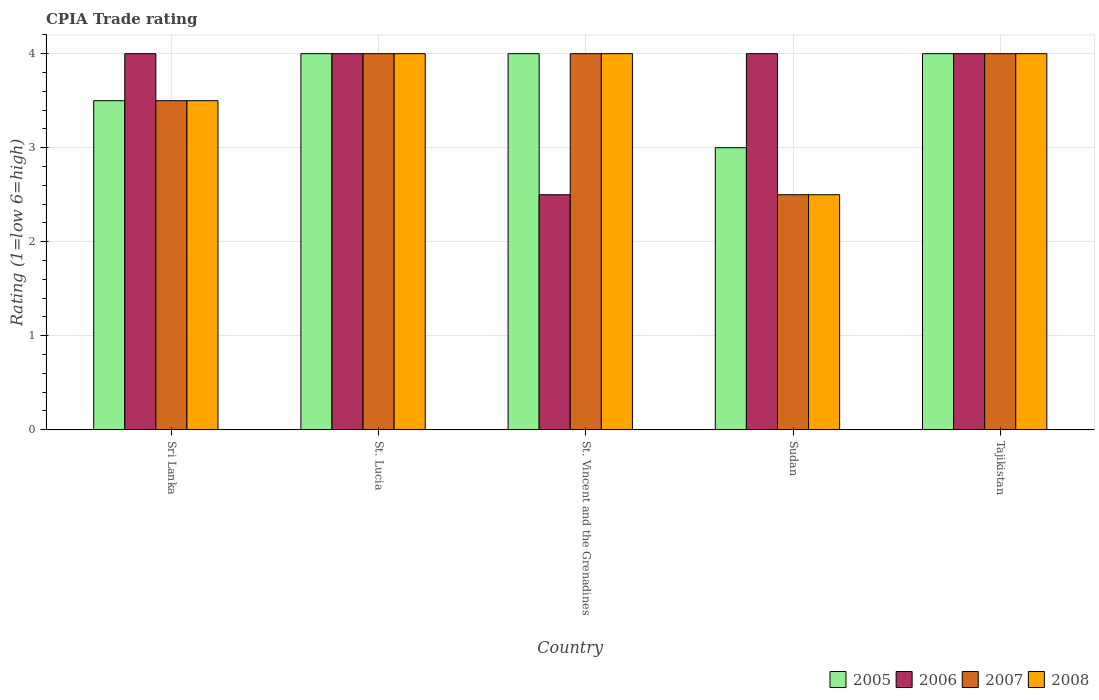How many different coloured bars are there?
Make the answer very short. 4. Are the number of bars on each tick of the X-axis equal?
Give a very brief answer. Yes. How many bars are there on the 5th tick from the left?
Provide a short and direct response. 4. What is the label of the 4th group of bars from the left?
Your answer should be very brief. Sudan. What is the CPIA rating in 2006 in St. Vincent and the Grenadines?
Ensure brevity in your answer.  2.5. Across all countries, what is the maximum CPIA rating in 2007?
Ensure brevity in your answer.  4. In which country was the CPIA rating in 2008 maximum?
Offer a very short reply. St. Lucia. In which country was the CPIA rating in 2005 minimum?
Give a very brief answer. Sudan. What is the total CPIA rating in 2008 in the graph?
Your response must be concise. 18. What is the difference between the CPIA rating in 2008 in St. Vincent and the Grenadines and that in Tajikistan?
Make the answer very short. 0. What is the difference between the CPIA rating in 2006 in St. Lucia and the CPIA rating in 2005 in St. Vincent and the Grenadines?
Give a very brief answer. 0. What is the average CPIA rating in 2007 per country?
Offer a terse response. 3.6. What is the difference between the CPIA rating of/in 2005 and CPIA rating of/in 2006 in Sudan?
Provide a succinct answer. -1. In how many countries, is the CPIA rating in 2005 greater than 1.4?
Offer a very short reply. 5. What is the ratio of the CPIA rating in 2006 in Sudan to that in Tajikistan?
Your answer should be very brief. 1. Is the CPIA rating in 2007 in Sri Lanka less than that in St. Lucia?
Offer a very short reply. Yes. What is the difference between the highest and the lowest CPIA rating in 2007?
Ensure brevity in your answer.  1.5. In how many countries, is the CPIA rating in 2007 greater than the average CPIA rating in 2007 taken over all countries?
Your response must be concise. 3. Is the sum of the CPIA rating in 2006 in St. Lucia and Tajikistan greater than the maximum CPIA rating in 2005 across all countries?
Your response must be concise. Yes. Is it the case that in every country, the sum of the CPIA rating in 2008 and CPIA rating in 2005 is greater than the CPIA rating in 2006?
Provide a short and direct response. Yes. Are all the bars in the graph horizontal?
Offer a very short reply. No. How many countries are there in the graph?
Ensure brevity in your answer.  5. What is the difference between two consecutive major ticks on the Y-axis?
Provide a succinct answer. 1. Does the graph contain any zero values?
Provide a short and direct response. No. What is the title of the graph?
Give a very brief answer. CPIA Trade rating. Does "1991" appear as one of the legend labels in the graph?
Offer a terse response. No. What is the label or title of the X-axis?
Provide a short and direct response. Country. What is the label or title of the Y-axis?
Provide a succinct answer. Rating (1=low 6=high). What is the Rating (1=low 6=high) in 2006 in Sri Lanka?
Offer a terse response. 4. What is the Rating (1=low 6=high) in 2006 in St. Lucia?
Offer a very short reply. 4. What is the Rating (1=low 6=high) in 2005 in St. Vincent and the Grenadines?
Offer a very short reply. 4. What is the Rating (1=low 6=high) in 2006 in St. Vincent and the Grenadines?
Your response must be concise. 2.5. What is the Rating (1=low 6=high) in 2006 in Sudan?
Give a very brief answer. 4. What is the Rating (1=low 6=high) in 2005 in Tajikistan?
Keep it short and to the point. 4. What is the Rating (1=low 6=high) in 2006 in Tajikistan?
Your answer should be very brief. 4. What is the Rating (1=low 6=high) of 2007 in Tajikistan?
Provide a short and direct response. 4. Across all countries, what is the maximum Rating (1=low 6=high) of 2006?
Your answer should be compact. 4. Across all countries, what is the minimum Rating (1=low 6=high) in 2006?
Provide a succinct answer. 2.5. Across all countries, what is the minimum Rating (1=low 6=high) of 2008?
Keep it short and to the point. 2.5. What is the total Rating (1=low 6=high) of 2005 in the graph?
Your answer should be very brief. 18.5. What is the total Rating (1=low 6=high) of 2007 in the graph?
Make the answer very short. 18. What is the difference between the Rating (1=low 6=high) of 2007 in Sri Lanka and that in St. Lucia?
Your response must be concise. -0.5. What is the difference between the Rating (1=low 6=high) of 2008 in Sri Lanka and that in St. Lucia?
Make the answer very short. -0.5. What is the difference between the Rating (1=low 6=high) in 2005 in Sri Lanka and that in St. Vincent and the Grenadines?
Ensure brevity in your answer.  -0.5. What is the difference between the Rating (1=low 6=high) of 2006 in Sri Lanka and that in St. Vincent and the Grenadines?
Make the answer very short. 1.5. What is the difference between the Rating (1=low 6=high) of 2008 in Sri Lanka and that in St. Vincent and the Grenadines?
Offer a terse response. -0.5. What is the difference between the Rating (1=low 6=high) of 2005 in Sri Lanka and that in Sudan?
Make the answer very short. 0.5. What is the difference between the Rating (1=low 6=high) of 2007 in Sri Lanka and that in Tajikistan?
Offer a very short reply. -0.5. What is the difference between the Rating (1=low 6=high) in 2008 in Sri Lanka and that in Tajikistan?
Provide a short and direct response. -0.5. What is the difference between the Rating (1=low 6=high) of 2005 in St. Lucia and that in St. Vincent and the Grenadines?
Your answer should be very brief. 0. What is the difference between the Rating (1=low 6=high) of 2007 in St. Lucia and that in St. Vincent and the Grenadines?
Your answer should be very brief. 0. What is the difference between the Rating (1=low 6=high) in 2006 in St. Lucia and that in Sudan?
Keep it short and to the point. 0. What is the difference between the Rating (1=low 6=high) in 2005 in St. Lucia and that in Tajikistan?
Your answer should be very brief. 0. What is the difference between the Rating (1=low 6=high) in 2007 in St. Lucia and that in Tajikistan?
Provide a succinct answer. 0. What is the difference between the Rating (1=low 6=high) of 2006 in St. Vincent and the Grenadines and that in Sudan?
Give a very brief answer. -1.5. What is the difference between the Rating (1=low 6=high) of 2007 in St. Vincent and the Grenadines and that in Sudan?
Your answer should be very brief. 1.5. What is the difference between the Rating (1=low 6=high) in 2006 in St. Vincent and the Grenadines and that in Tajikistan?
Provide a short and direct response. -1.5. What is the difference between the Rating (1=low 6=high) of 2006 in Sudan and that in Tajikistan?
Give a very brief answer. 0. What is the difference between the Rating (1=low 6=high) of 2007 in Sudan and that in Tajikistan?
Your answer should be compact. -1.5. What is the difference between the Rating (1=low 6=high) of 2008 in Sudan and that in Tajikistan?
Your answer should be very brief. -1.5. What is the difference between the Rating (1=low 6=high) of 2005 in Sri Lanka and the Rating (1=low 6=high) of 2008 in St. Lucia?
Your response must be concise. -0.5. What is the difference between the Rating (1=low 6=high) of 2006 in Sri Lanka and the Rating (1=low 6=high) of 2007 in St. Lucia?
Provide a succinct answer. 0. What is the difference between the Rating (1=low 6=high) in 2006 in Sri Lanka and the Rating (1=low 6=high) in 2008 in St. Lucia?
Keep it short and to the point. 0. What is the difference between the Rating (1=low 6=high) of 2007 in Sri Lanka and the Rating (1=low 6=high) of 2008 in St. Lucia?
Offer a terse response. -0.5. What is the difference between the Rating (1=low 6=high) in 2005 in Sri Lanka and the Rating (1=low 6=high) in 2006 in St. Vincent and the Grenadines?
Provide a succinct answer. 1. What is the difference between the Rating (1=low 6=high) of 2005 in Sri Lanka and the Rating (1=low 6=high) of 2008 in St. Vincent and the Grenadines?
Make the answer very short. -0.5. What is the difference between the Rating (1=low 6=high) in 2005 in Sri Lanka and the Rating (1=low 6=high) in 2007 in Sudan?
Your answer should be compact. 1. What is the difference between the Rating (1=low 6=high) in 2006 in Sri Lanka and the Rating (1=low 6=high) in 2008 in Sudan?
Ensure brevity in your answer.  1.5. What is the difference between the Rating (1=low 6=high) of 2005 in Sri Lanka and the Rating (1=low 6=high) of 2006 in Tajikistan?
Make the answer very short. -0.5. What is the difference between the Rating (1=low 6=high) of 2006 in Sri Lanka and the Rating (1=low 6=high) of 2008 in Tajikistan?
Provide a succinct answer. 0. What is the difference between the Rating (1=low 6=high) in 2005 in St. Lucia and the Rating (1=low 6=high) in 2007 in St. Vincent and the Grenadines?
Offer a terse response. 0. What is the difference between the Rating (1=low 6=high) in 2006 in St. Lucia and the Rating (1=low 6=high) in 2008 in St. Vincent and the Grenadines?
Your answer should be compact. 0. What is the difference between the Rating (1=low 6=high) of 2005 in St. Lucia and the Rating (1=low 6=high) of 2006 in Sudan?
Ensure brevity in your answer.  0. What is the difference between the Rating (1=low 6=high) of 2006 in St. Lucia and the Rating (1=low 6=high) of 2008 in Sudan?
Offer a very short reply. 1.5. What is the difference between the Rating (1=low 6=high) in 2007 in St. Lucia and the Rating (1=low 6=high) in 2008 in Sudan?
Offer a terse response. 1.5. What is the difference between the Rating (1=low 6=high) in 2005 in St. Lucia and the Rating (1=low 6=high) in 2006 in Tajikistan?
Your answer should be compact. 0. What is the difference between the Rating (1=low 6=high) in 2005 in St. Lucia and the Rating (1=low 6=high) in 2008 in Tajikistan?
Give a very brief answer. 0. What is the difference between the Rating (1=low 6=high) of 2006 in St. Lucia and the Rating (1=low 6=high) of 2008 in Tajikistan?
Keep it short and to the point. 0. What is the difference between the Rating (1=low 6=high) of 2007 in St. Lucia and the Rating (1=low 6=high) of 2008 in Tajikistan?
Your answer should be compact. 0. What is the difference between the Rating (1=low 6=high) in 2006 in St. Vincent and the Grenadines and the Rating (1=low 6=high) in 2008 in Sudan?
Keep it short and to the point. 0. What is the difference between the Rating (1=low 6=high) of 2005 in St. Vincent and the Grenadines and the Rating (1=low 6=high) of 2006 in Tajikistan?
Provide a succinct answer. 0. What is the difference between the Rating (1=low 6=high) of 2005 in St. Vincent and the Grenadines and the Rating (1=low 6=high) of 2007 in Tajikistan?
Offer a very short reply. 0. What is the difference between the Rating (1=low 6=high) of 2005 in Sudan and the Rating (1=low 6=high) of 2008 in Tajikistan?
Offer a very short reply. -1. What is the difference between the Rating (1=low 6=high) of 2007 in Sudan and the Rating (1=low 6=high) of 2008 in Tajikistan?
Your answer should be very brief. -1.5. What is the average Rating (1=low 6=high) in 2005 per country?
Offer a terse response. 3.7. What is the average Rating (1=low 6=high) in 2006 per country?
Make the answer very short. 3.7. What is the average Rating (1=low 6=high) in 2007 per country?
Give a very brief answer. 3.6. What is the average Rating (1=low 6=high) of 2008 per country?
Your response must be concise. 3.6. What is the difference between the Rating (1=low 6=high) in 2005 and Rating (1=low 6=high) in 2006 in Sri Lanka?
Give a very brief answer. -0.5. What is the difference between the Rating (1=low 6=high) in 2007 and Rating (1=low 6=high) in 2008 in St. Lucia?
Ensure brevity in your answer.  0. What is the difference between the Rating (1=low 6=high) in 2007 and Rating (1=low 6=high) in 2008 in St. Vincent and the Grenadines?
Your response must be concise. 0. What is the difference between the Rating (1=low 6=high) in 2005 and Rating (1=low 6=high) in 2008 in Sudan?
Give a very brief answer. 0.5. What is the difference between the Rating (1=low 6=high) of 2006 and Rating (1=low 6=high) of 2007 in Sudan?
Ensure brevity in your answer.  1.5. What is the difference between the Rating (1=low 6=high) of 2006 and Rating (1=low 6=high) of 2008 in Sudan?
Your response must be concise. 1.5. What is the difference between the Rating (1=low 6=high) of 2007 and Rating (1=low 6=high) of 2008 in Sudan?
Your answer should be compact. 0. What is the difference between the Rating (1=low 6=high) of 2005 and Rating (1=low 6=high) of 2006 in Tajikistan?
Give a very brief answer. 0. What is the difference between the Rating (1=low 6=high) of 2005 and Rating (1=low 6=high) of 2007 in Tajikistan?
Give a very brief answer. 0. What is the difference between the Rating (1=low 6=high) of 2006 and Rating (1=low 6=high) of 2007 in Tajikistan?
Make the answer very short. 0. What is the difference between the Rating (1=low 6=high) in 2006 and Rating (1=low 6=high) in 2008 in Tajikistan?
Your response must be concise. 0. What is the difference between the Rating (1=low 6=high) in 2007 and Rating (1=low 6=high) in 2008 in Tajikistan?
Your answer should be very brief. 0. What is the ratio of the Rating (1=low 6=high) in 2005 in Sri Lanka to that in St. Lucia?
Provide a succinct answer. 0.88. What is the ratio of the Rating (1=low 6=high) in 2005 in Sri Lanka to that in St. Vincent and the Grenadines?
Make the answer very short. 0.88. What is the ratio of the Rating (1=low 6=high) in 2005 in Sri Lanka to that in Sudan?
Keep it short and to the point. 1.17. What is the ratio of the Rating (1=low 6=high) of 2006 in Sri Lanka to that in Sudan?
Provide a succinct answer. 1. What is the ratio of the Rating (1=low 6=high) in 2007 in Sri Lanka to that in Sudan?
Provide a succinct answer. 1.4. What is the ratio of the Rating (1=low 6=high) in 2005 in Sri Lanka to that in Tajikistan?
Ensure brevity in your answer.  0.88. What is the ratio of the Rating (1=low 6=high) of 2007 in Sri Lanka to that in Tajikistan?
Your answer should be very brief. 0.88. What is the ratio of the Rating (1=low 6=high) in 2008 in Sri Lanka to that in Tajikistan?
Ensure brevity in your answer.  0.88. What is the ratio of the Rating (1=low 6=high) in 2006 in St. Lucia to that in Sudan?
Offer a very short reply. 1. What is the ratio of the Rating (1=low 6=high) of 2007 in St. Lucia to that in Sudan?
Give a very brief answer. 1.6. What is the ratio of the Rating (1=low 6=high) in 2008 in St. Lucia to that in Sudan?
Make the answer very short. 1.6. What is the ratio of the Rating (1=low 6=high) of 2008 in St. Lucia to that in Tajikistan?
Make the answer very short. 1. What is the ratio of the Rating (1=low 6=high) in 2005 in St. Vincent and the Grenadines to that in Sudan?
Your response must be concise. 1.33. What is the ratio of the Rating (1=low 6=high) of 2007 in St. Vincent and the Grenadines to that in Sudan?
Your answer should be compact. 1.6. What is the ratio of the Rating (1=low 6=high) in 2005 in St. Vincent and the Grenadines to that in Tajikistan?
Offer a very short reply. 1. What is the ratio of the Rating (1=low 6=high) in 2006 in St. Vincent and the Grenadines to that in Tajikistan?
Offer a very short reply. 0.62. What is the ratio of the Rating (1=low 6=high) of 2007 in St. Vincent and the Grenadines to that in Tajikistan?
Give a very brief answer. 1. What is the ratio of the Rating (1=low 6=high) of 2005 in Sudan to that in Tajikistan?
Offer a very short reply. 0.75. What is the ratio of the Rating (1=low 6=high) of 2006 in Sudan to that in Tajikistan?
Ensure brevity in your answer.  1. What is the ratio of the Rating (1=low 6=high) in 2007 in Sudan to that in Tajikistan?
Your response must be concise. 0.62. What is the ratio of the Rating (1=low 6=high) in 2008 in Sudan to that in Tajikistan?
Offer a very short reply. 0.62. What is the difference between the highest and the second highest Rating (1=low 6=high) of 2006?
Provide a short and direct response. 0. What is the difference between the highest and the lowest Rating (1=low 6=high) of 2005?
Your answer should be very brief. 1. What is the difference between the highest and the lowest Rating (1=low 6=high) in 2006?
Ensure brevity in your answer.  1.5. 